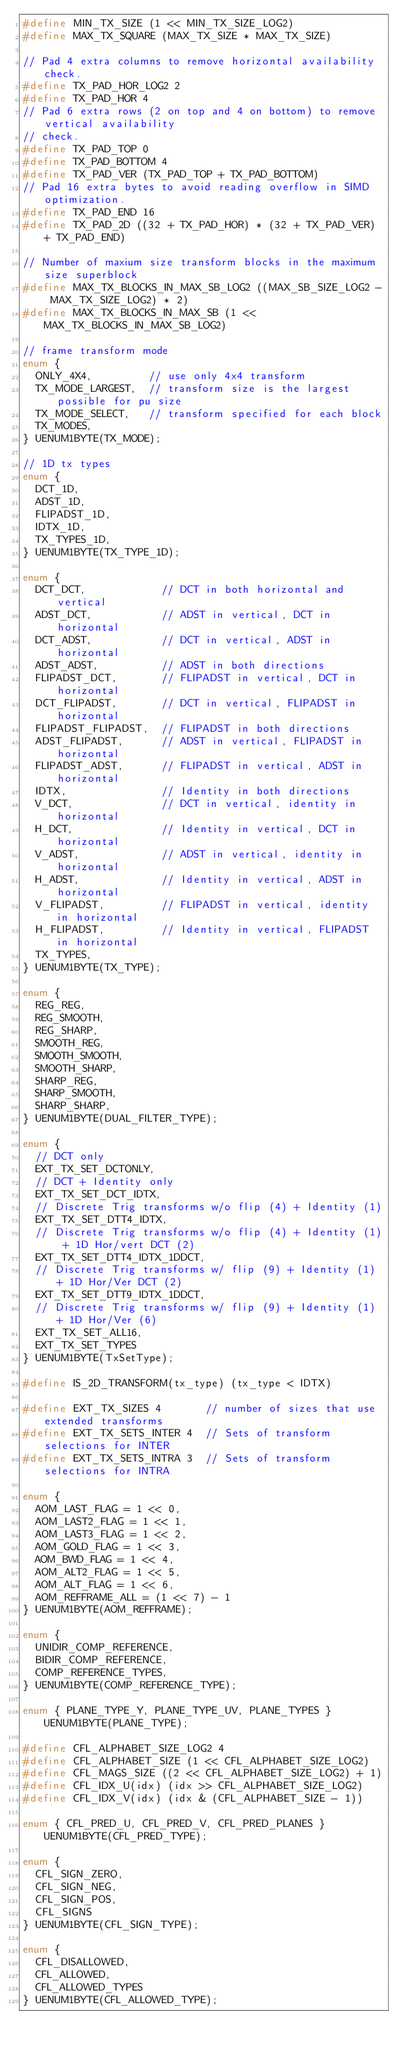<code> <loc_0><loc_0><loc_500><loc_500><_C_>#define MIN_TX_SIZE (1 << MIN_TX_SIZE_LOG2)
#define MAX_TX_SQUARE (MAX_TX_SIZE * MAX_TX_SIZE)

// Pad 4 extra columns to remove horizontal availability check.
#define TX_PAD_HOR_LOG2 2
#define TX_PAD_HOR 4
// Pad 6 extra rows (2 on top and 4 on bottom) to remove vertical availability
// check.
#define TX_PAD_TOP 0
#define TX_PAD_BOTTOM 4
#define TX_PAD_VER (TX_PAD_TOP + TX_PAD_BOTTOM)
// Pad 16 extra bytes to avoid reading overflow in SIMD optimization.
#define TX_PAD_END 16
#define TX_PAD_2D ((32 + TX_PAD_HOR) * (32 + TX_PAD_VER) + TX_PAD_END)

// Number of maxium size transform blocks in the maximum size superblock
#define MAX_TX_BLOCKS_IN_MAX_SB_LOG2 ((MAX_SB_SIZE_LOG2 - MAX_TX_SIZE_LOG2) * 2)
#define MAX_TX_BLOCKS_IN_MAX_SB (1 << MAX_TX_BLOCKS_IN_MAX_SB_LOG2)

// frame transform mode
enum {
  ONLY_4X4,         // use only 4x4 transform
  TX_MODE_LARGEST,  // transform size is the largest possible for pu size
  TX_MODE_SELECT,   // transform specified for each block
  TX_MODES,
} UENUM1BYTE(TX_MODE);

// 1D tx types
enum {
  DCT_1D,
  ADST_1D,
  FLIPADST_1D,
  IDTX_1D,
  TX_TYPES_1D,
} UENUM1BYTE(TX_TYPE_1D);

enum {
  DCT_DCT,            // DCT in both horizontal and vertical
  ADST_DCT,           // ADST in vertical, DCT in horizontal
  DCT_ADST,           // DCT in vertical, ADST in horizontal
  ADST_ADST,          // ADST in both directions
  FLIPADST_DCT,       // FLIPADST in vertical, DCT in horizontal
  DCT_FLIPADST,       // DCT in vertical, FLIPADST in horizontal
  FLIPADST_FLIPADST,  // FLIPADST in both directions
  ADST_FLIPADST,      // ADST in vertical, FLIPADST in horizontal
  FLIPADST_ADST,      // FLIPADST in vertical, ADST in horizontal
  IDTX,               // Identity in both directions
  V_DCT,              // DCT in vertical, identity in horizontal
  H_DCT,              // Identity in vertical, DCT in horizontal
  V_ADST,             // ADST in vertical, identity in horizontal
  H_ADST,             // Identity in vertical, ADST in horizontal
  V_FLIPADST,         // FLIPADST in vertical, identity in horizontal
  H_FLIPADST,         // Identity in vertical, FLIPADST in horizontal
  TX_TYPES,
} UENUM1BYTE(TX_TYPE);

enum {
  REG_REG,
  REG_SMOOTH,
  REG_SHARP,
  SMOOTH_REG,
  SMOOTH_SMOOTH,
  SMOOTH_SHARP,
  SHARP_REG,
  SHARP_SMOOTH,
  SHARP_SHARP,
} UENUM1BYTE(DUAL_FILTER_TYPE);

enum {
  // DCT only
  EXT_TX_SET_DCTONLY,
  // DCT + Identity only
  EXT_TX_SET_DCT_IDTX,
  // Discrete Trig transforms w/o flip (4) + Identity (1)
  EXT_TX_SET_DTT4_IDTX,
  // Discrete Trig transforms w/o flip (4) + Identity (1) + 1D Hor/vert DCT (2)
  EXT_TX_SET_DTT4_IDTX_1DDCT,
  // Discrete Trig transforms w/ flip (9) + Identity (1) + 1D Hor/Ver DCT (2)
  EXT_TX_SET_DTT9_IDTX_1DDCT,
  // Discrete Trig transforms w/ flip (9) + Identity (1) + 1D Hor/Ver (6)
  EXT_TX_SET_ALL16,
  EXT_TX_SET_TYPES
} UENUM1BYTE(TxSetType);

#define IS_2D_TRANSFORM(tx_type) (tx_type < IDTX)

#define EXT_TX_SIZES 4       // number of sizes that use extended transforms
#define EXT_TX_SETS_INTER 4  // Sets of transform selections for INTER
#define EXT_TX_SETS_INTRA 3  // Sets of transform selections for INTRA

enum {
  AOM_LAST_FLAG = 1 << 0,
  AOM_LAST2_FLAG = 1 << 1,
  AOM_LAST3_FLAG = 1 << 2,
  AOM_GOLD_FLAG = 1 << 3,
  AOM_BWD_FLAG = 1 << 4,
  AOM_ALT2_FLAG = 1 << 5,
  AOM_ALT_FLAG = 1 << 6,
  AOM_REFFRAME_ALL = (1 << 7) - 1
} UENUM1BYTE(AOM_REFFRAME);

enum {
  UNIDIR_COMP_REFERENCE,
  BIDIR_COMP_REFERENCE,
  COMP_REFERENCE_TYPES,
} UENUM1BYTE(COMP_REFERENCE_TYPE);

enum { PLANE_TYPE_Y, PLANE_TYPE_UV, PLANE_TYPES } UENUM1BYTE(PLANE_TYPE);

#define CFL_ALPHABET_SIZE_LOG2 4
#define CFL_ALPHABET_SIZE (1 << CFL_ALPHABET_SIZE_LOG2)
#define CFL_MAGS_SIZE ((2 << CFL_ALPHABET_SIZE_LOG2) + 1)
#define CFL_IDX_U(idx) (idx >> CFL_ALPHABET_SIZE_LOG2)
#define CFL_IDX_V(idx) (idx & (CFL_ALPHABET_SIZE - 1))

enum { CFL_PRED_U, CFL_PRED_V, CFL_PRED_PLANES } UENUM1BYTE(CFL_PRED_TYPE);

enum {
  CFL_SIGN_ZERO,
  CFL_SIGN_NEG,
  CFL_SIGN_POS,
  CFL_SIGNS
} UENUM1BYTE(CFL_SIGN_TYPE);

enum {
  CFL_DISALLOWED,
  CFL_ALLOWED,
  CFL_ALLOWED_TYPES
} UENUM1BYTE(CFL_ALLOWED_TYPE);
</code> 